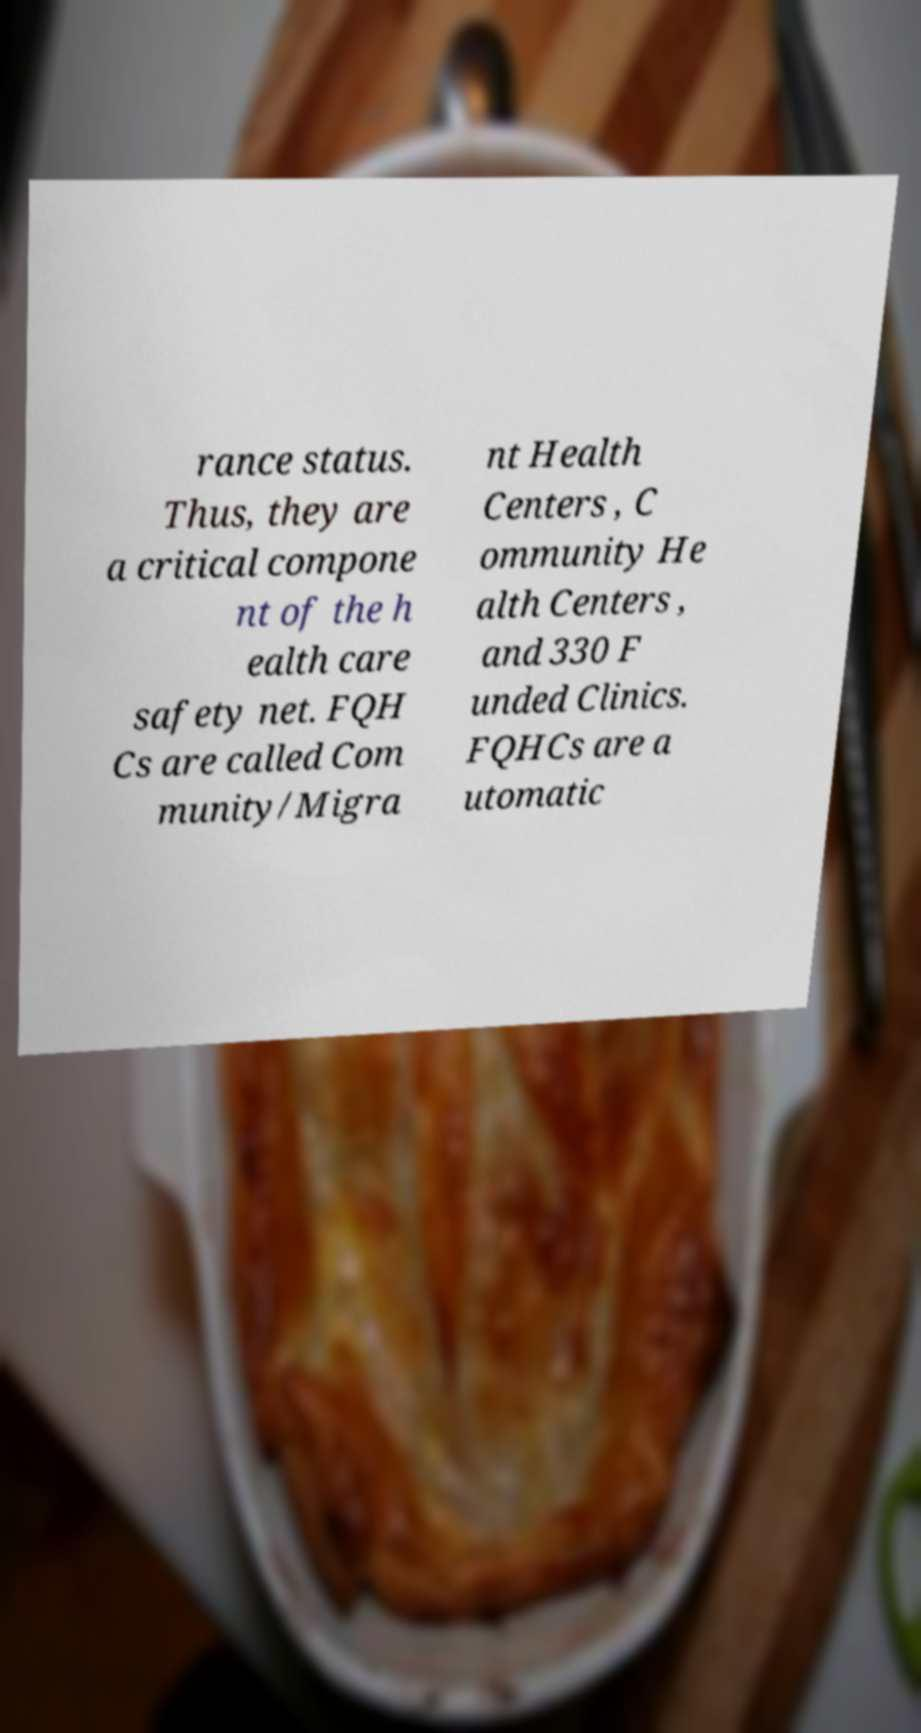For documentation purposes, I need the text within this image transcribed. Could you provide that? rance status. Thus, they are a critical compone nt of the h ealth care safety net. FQH Cs are called Com munity/Migra nt Health Centers , C ommunity He alth Centers , and 330 F unded Clinics. FQHCs are a utomatic 